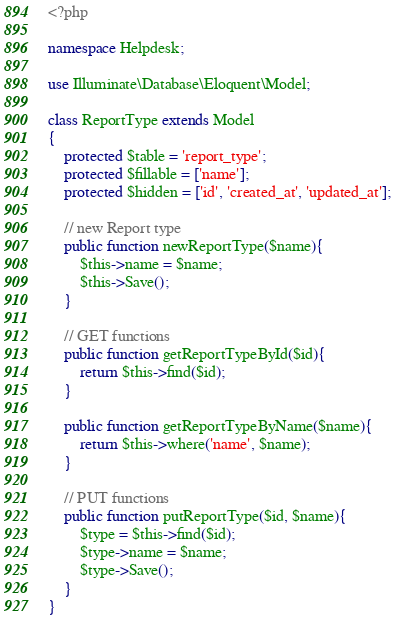<code> <loc_0><loc_0><loc_500><loc_500><_PHP_><?php

namespace Helpdesk;

use Illuminate\Database\Eloquent\Model;

class ReportType extends Model
{
    protected $table = 'report_type';
    protected $fillable = ['name'];
    protected $hidden = ['id', 'created_at', 'updated_at'];

    // new Report type
    public function newReportType($name){
    	$this->name = $name;
    	$this->Save();
    }

    // GET functions
    public function getReportTypeById($id){
    	return $this->find($id);
    }

    public function getReportTypeByName($name){
    	return $this->where('name', $name);
    }

    // PUT functions
    public function putReportType($id, $name){
    	$type = $this->find($id);
    	$type->name = $name;
    	$type->Save();
    }
}
</code> 